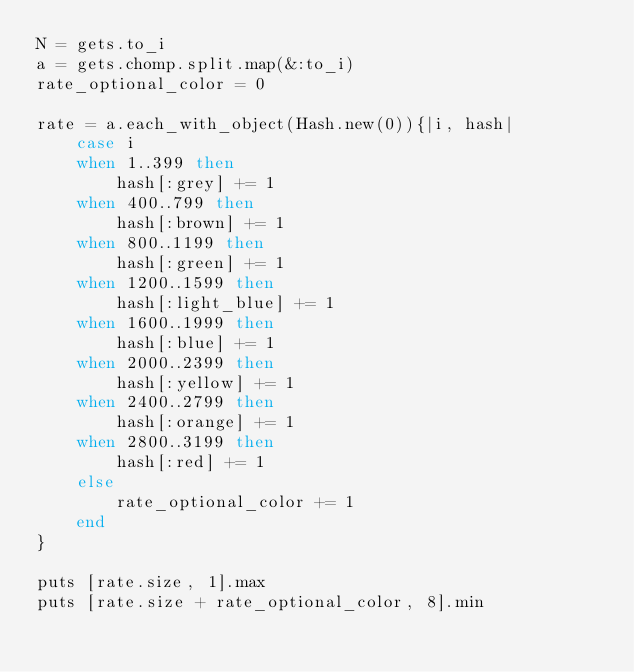<code> <loc_0><loc_0><loc_500><loc_500><_Ruby_>N = gets.to_i
a = gets.chomp.split.map(&:to_i)
rate_optional_color = 0

rate = a.each_with_object(Hash.new(0)){|i, hash|
    case i
    when 1..399 then
        hash[:grey] += 1
    when 400..799 then
        hash[:brown] += 1
    when 800..1199 then
        hash[:green] += 1
    when 1200..1599 then
        hash[:light_blue] += 1
    when 1600..1999 then
        hash[:blue] += 1
    when 2000..2399 then
        hash[:yellow] += 1
    when 2400..2799 then
        hash[:orange] += 1
    when 2800..3199 then
        hash[:red] += 1
    else
        rate_optional_color += 1
    end
}

puts [rate.size, 1].max
puts [rate.size + rate_optional_color, 8].min</code> 